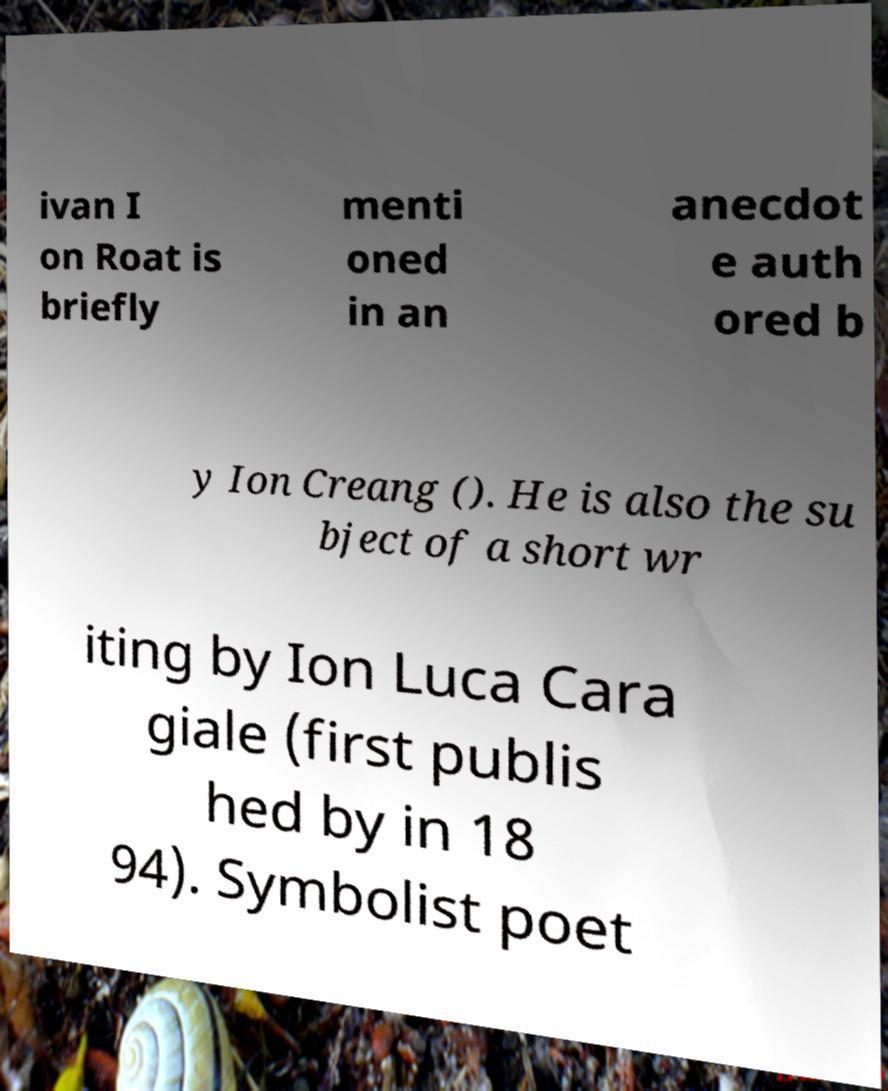Can you read and provide the text displayed in the image?This photo seems to have some interesting text. Can you extract and type it out for me? ivan I on Roat is briefly menti oned in an anecdot e auth ored b y Ion Creang (). He is also the su bject of a short wr iting by Ion Luca Cara giale (first publis hed by in 18 94). Symbolist poet 